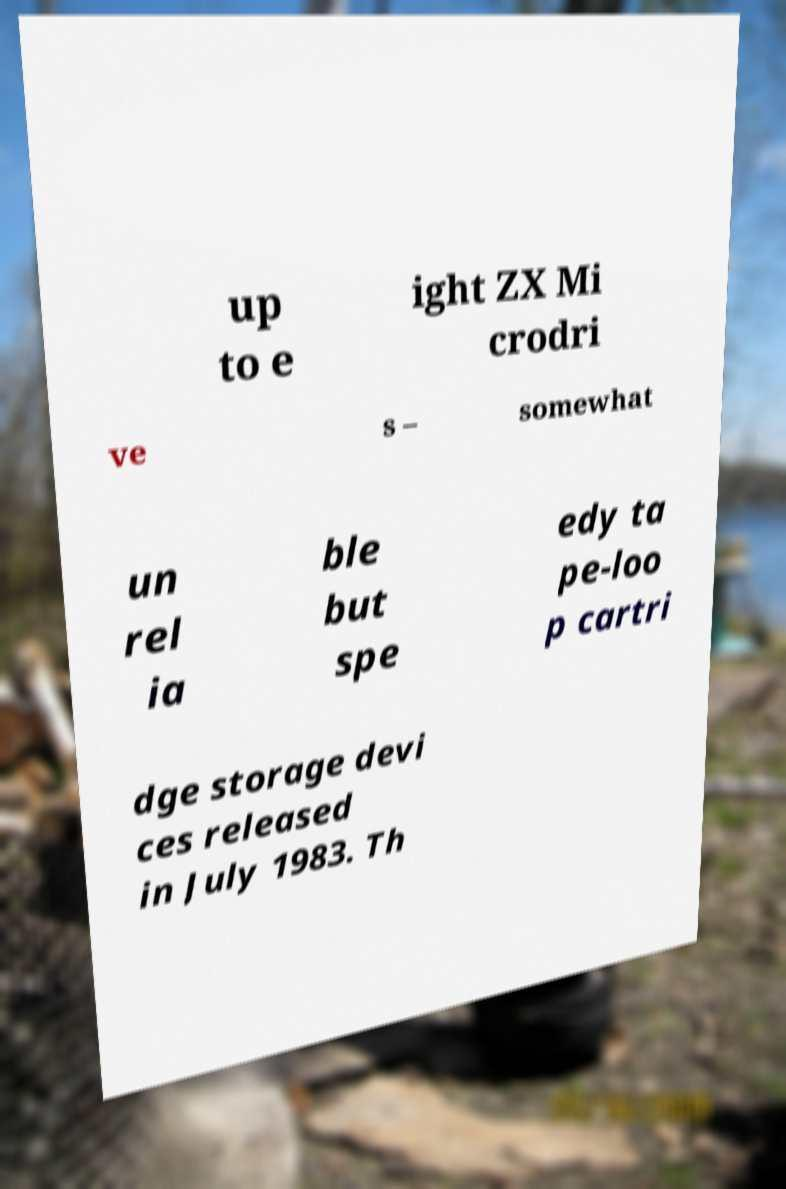Please read and relay the text visible in this image. What does it say? up to e ight ZX Mi crodri ve s – somewhat un rel ia ble but spe edy ta pe-loo p cartri dge storage devi ces released in July 1983. Th 